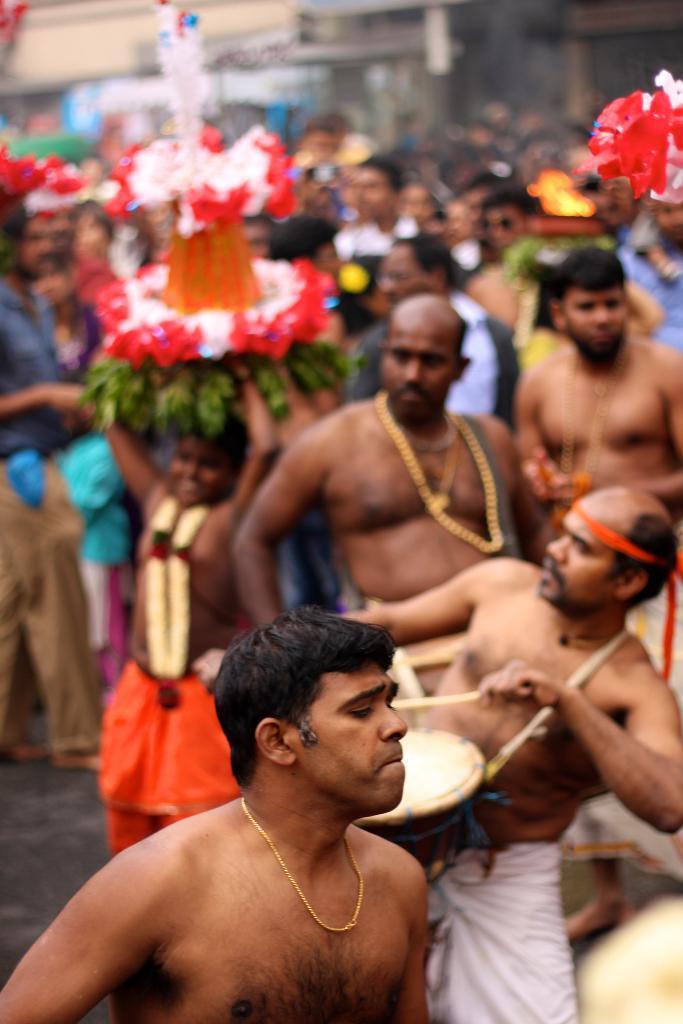In one or two sentences, can you explain what this image depicts? In this picture we can see a group of people on the road, chains, garland, sticks, drum and some objects and in the background we can see buildings and it is blurry. 